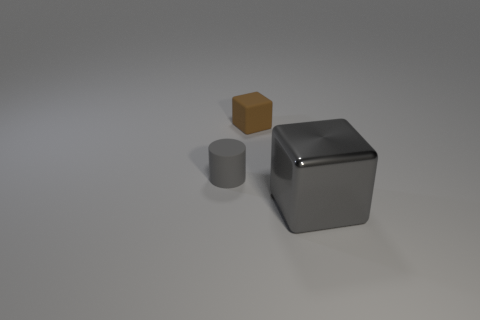Add 2 blocks. How many objects exist? 5 Subtract all brown cubes. How many cubes are left? 1 Subtract all cylinders. How many objects are left? 2 Subtract 1 cubes. How many cubes are left? 1 Subtract all green cylinders. Subtract all red balls. How many cylinders are left? 1 Subtract all brown cylinders. How many brown blocks are left? 1 Subtract all cylinders. Subtract all gray rubber balls. How many objects are left? 2 Add 1 tiny brown objects. How many tiny brown objects are left? 2 Add 3 big metallic blocks. How many big metallic blocks exist? 4 Subtract 0 gray balls. How many objects are left? 3 